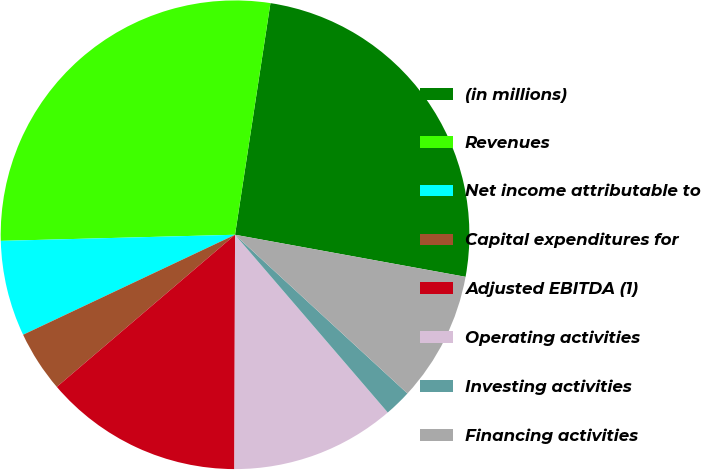Convert chart to OTSL. <chart><loc_0><loc_0><loc_500><loc_500><pie_chart><fcel>(in millions)<fcel>Revenues<fcel>Net income attributable to<fcel>Capital expenditures for<fcel>Adjusted EBITDA (1)<fcel>Operating activities<fcel>Investing activities<fcel>Financing activities<nl><fcel>25.46%<fcel>27.83%<fcel>6.6%<fcel>4.23%<fcel>13.71%<fcel>11.34%<fcel>1.86%<fcel>8.97%<nl></chart> 